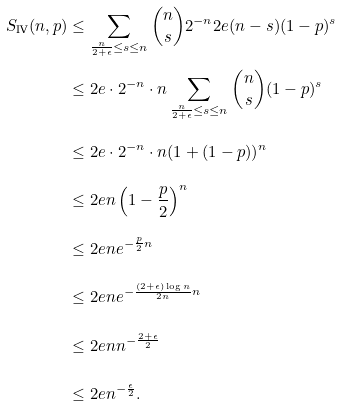Convert formula to latex. <formula><loc_0><loc_0><loc_500><loc_500>S _ { \text {IV} } ( n , p ) & \leq \sum _ { \frac { n } { 2 + \epsilon } \leq s \leq n } { n \choose s } 2 ^ { - n } 2 e ( n - s ) ( 1 - p ) ^ { s } \\ & \leq 2 e \cdot 2 ^ { - n } \cdot n \sum _ { \frac { n } { 2 + \epsilon } \leq s \leq n } { n \choose s } ( 1 - p ) ^ { s } \\ & \leq 2 e \cdot 2 ^ { - n } \cdot n ( 1 + ( 1 - p ) ) ^ { n } \\ & \leq 2 e n \left ( 1 - \frac { p } { 2 } \right ) ^ { n } \\ & \leq 2 e n e ^ { - \frac { p } { 2 } n } \\ & \leq 2 e n e ^ { - \frac { ( 2 + \epsilon ) \log n } { 2 n } n } \\ & \leq 2 e n n ^ { - \frac { 2 + \epsilon } { 2 } } \\ & \leq 2 e n ^ { - \frac { \epsilon } { 2 } } .</formula> 